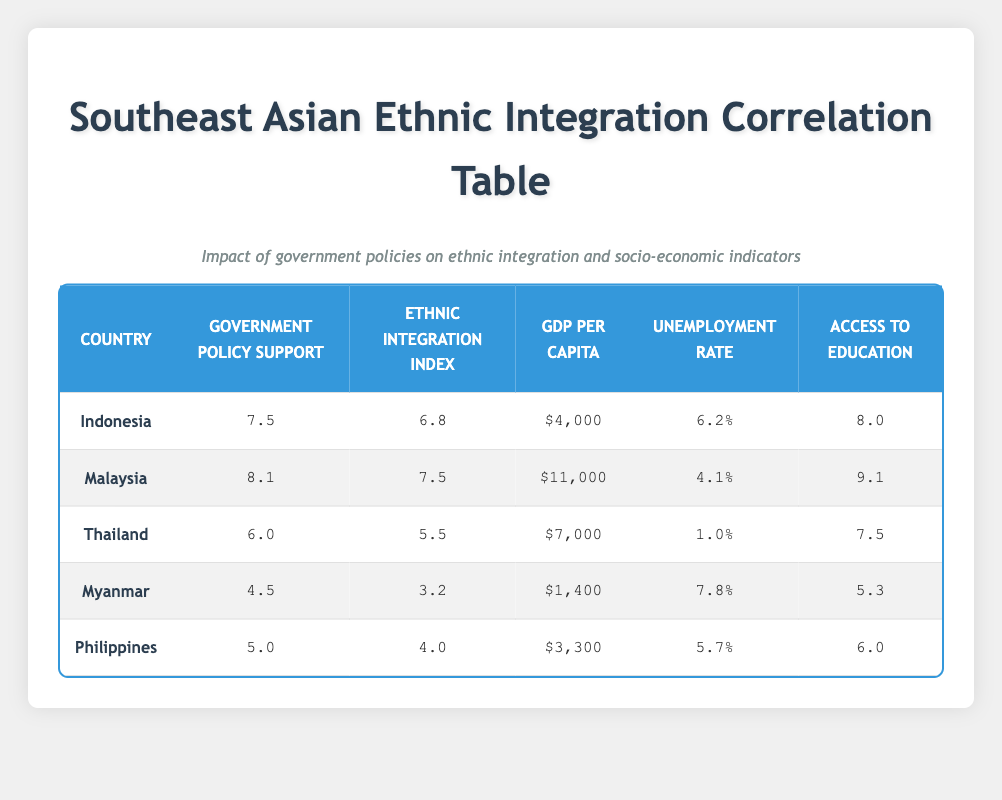What is the GDP per capita of Malaysia? The table lists Malaysia with a GDP per capita of $11,000. This can be found directly under the "GDP Per Capita" column for Malaysia.
Answer: $11,000 Which country has the highest Ethnic Integration Index? By examining the "Ethnic Integration Index" values, Malaysia has the highest score of 7.5. This value is directly listed in the corresponding row for Malaysia.
Answer: Malaysia What is the average Government Policy Support across all countries? To find the average, sum the Government Policy Support values: 7.5 + 8.1 + 6.0 + 4.5 + 5.0 = 31.1. Then, divide by the number of countries (5): 31.1 / 5 = 6.22.
Answer: 6.22 Is the Unemployment Rate in Thailand lower than in the Philippines? The unemployment rate for Thailand is 1.0%, while for the Philippines, it is 5.7%. Since 1.0% is less than 5.7%, the answer is yes.
Answer: Yes Which country has both the lowest GDP per capita and the highest unemployment rate? Upon reviewing the rows, Myanmar has a GDP per capita of $1,400 (the lowest) and an unemployment rate of 7.8% (the highest). Therefore, Myanmar matches both criteria.
Answer: Myanmar Do any countries have an Ethnic Integration Index above 6.5? Looking at the Ethnic Integration Index, Malaysia (7.5) and Indonesia (6.8) both have values above 6.5. Thus the answer is yes.
Answer: Yes What is the difference in Access to Education between Indonesia and Myanmar? Indonesia's Access to Education is 8.0, and Myanmar's is 5.3. To find the difference, subtract Myanmar's value from Indonesia's: 8.0 - 5.3 = 2.7.
Answer: 2.7 Which country has the highest Government Policy Support and what is the value? Scanning the table, Malaysia has the highest Government Policy Support at 8.1, listed in its respective row.
Answer: 8.1 Are there any countries where Access to Education is below 6.0? Checking the Access to Education column, Myanmar (5.3) and the Philippines (6.0) show values less than 6.0. Thus, the answer is yes.
Answer: Yes 